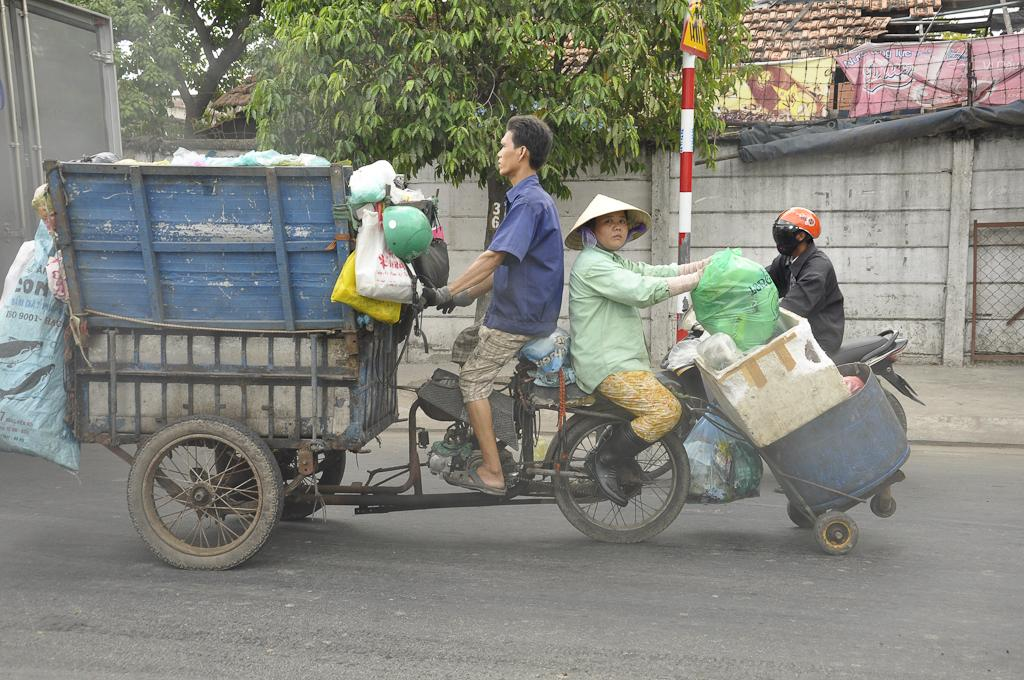What are the two people in the image doing? The two people are sitting in a garbage van on the road. What can be seen in the background of the image? There is a house, trees, a pole, and a person on a bike in the background. What invention is the person on the bike using to collect garbage in the image? There is no invention or garbage collection activity depicted in the image; the person on the bike is simply riding a bike in the background. 